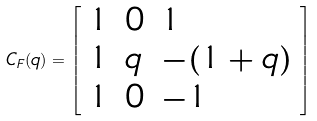Convert formula to latex. <formula><loc_0><loc_0><loc_500><loc_500>C _ { F } ( q ) = \left [ \begin{array} { l l l } { 1 } & { 0 } & { 1 } \\ { 1 } & { q } & { - ( 1 + q ) } \\ { 1 } & { 0 } & { - 1 } \end{array} \right ]</formula> 